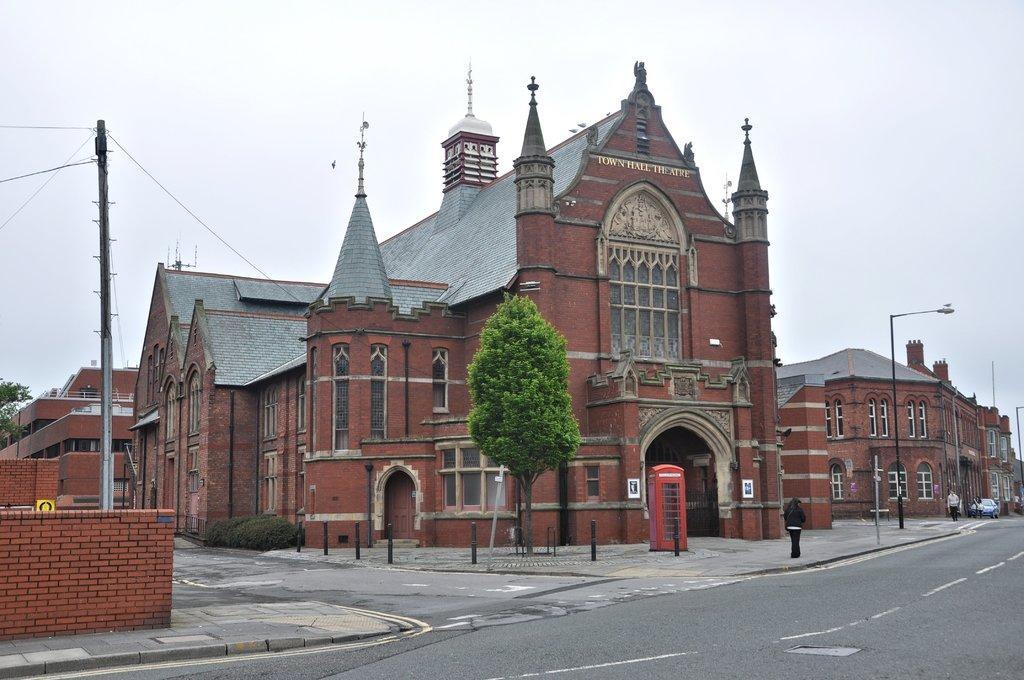Could you give a brief overview of what you see in this image? In the image we can see a building and these are the windows of the building. There is a phone booth, light pole, tree, plant, brick wall, electric pole, sky and a road. We can see there are even people wearing clothes, they are walking on the footpath, there is a vehicle on the road. 